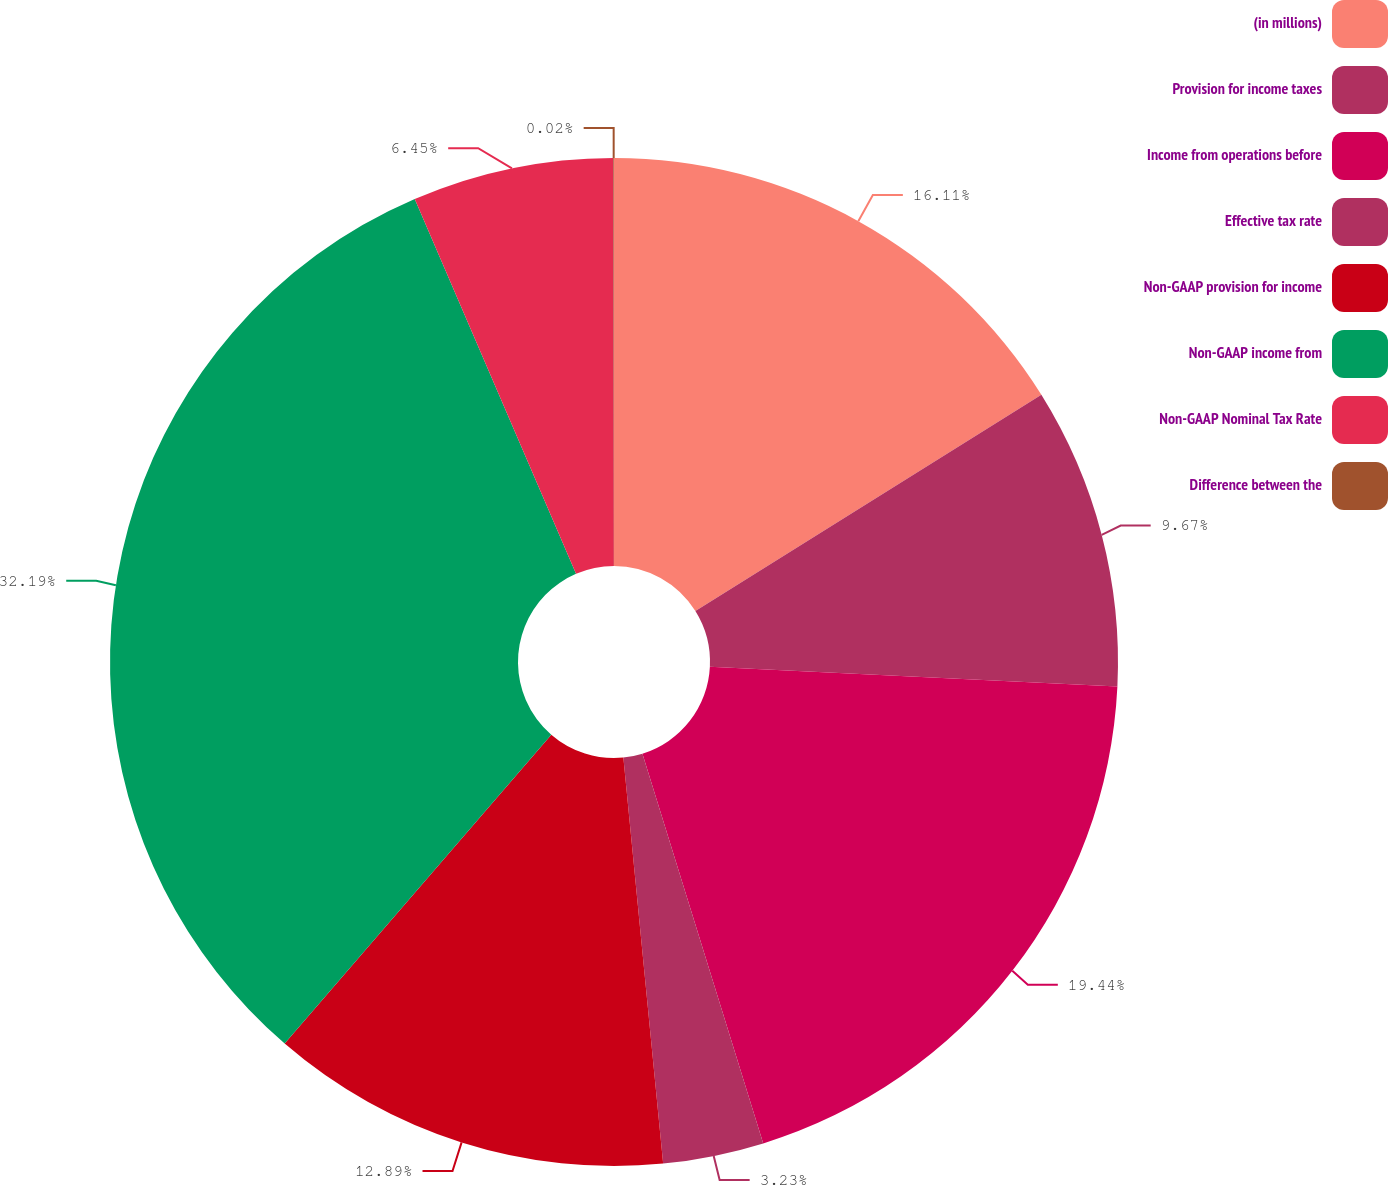<chart> <loc_0><loc_0><loc_500><loc_500><pie_chart><fcel>(in millions)<fcel>Provision for income taxes<fcel>Income from operations before<fcel>Effective tax rate<fcel>Non-GAAP provision for income<fcel>Non-GAAP income from<fcel>Non-GAAP Nominal Tax Rate<fcel>Difference between the<nl><fcel>16.11%<fcel>9.67%<fcel>19.44%<fcel>3.23%<fcel>12.89%<fcel>32.2%<fcel>6.45%<fcel>0.02%<nl></chart> 